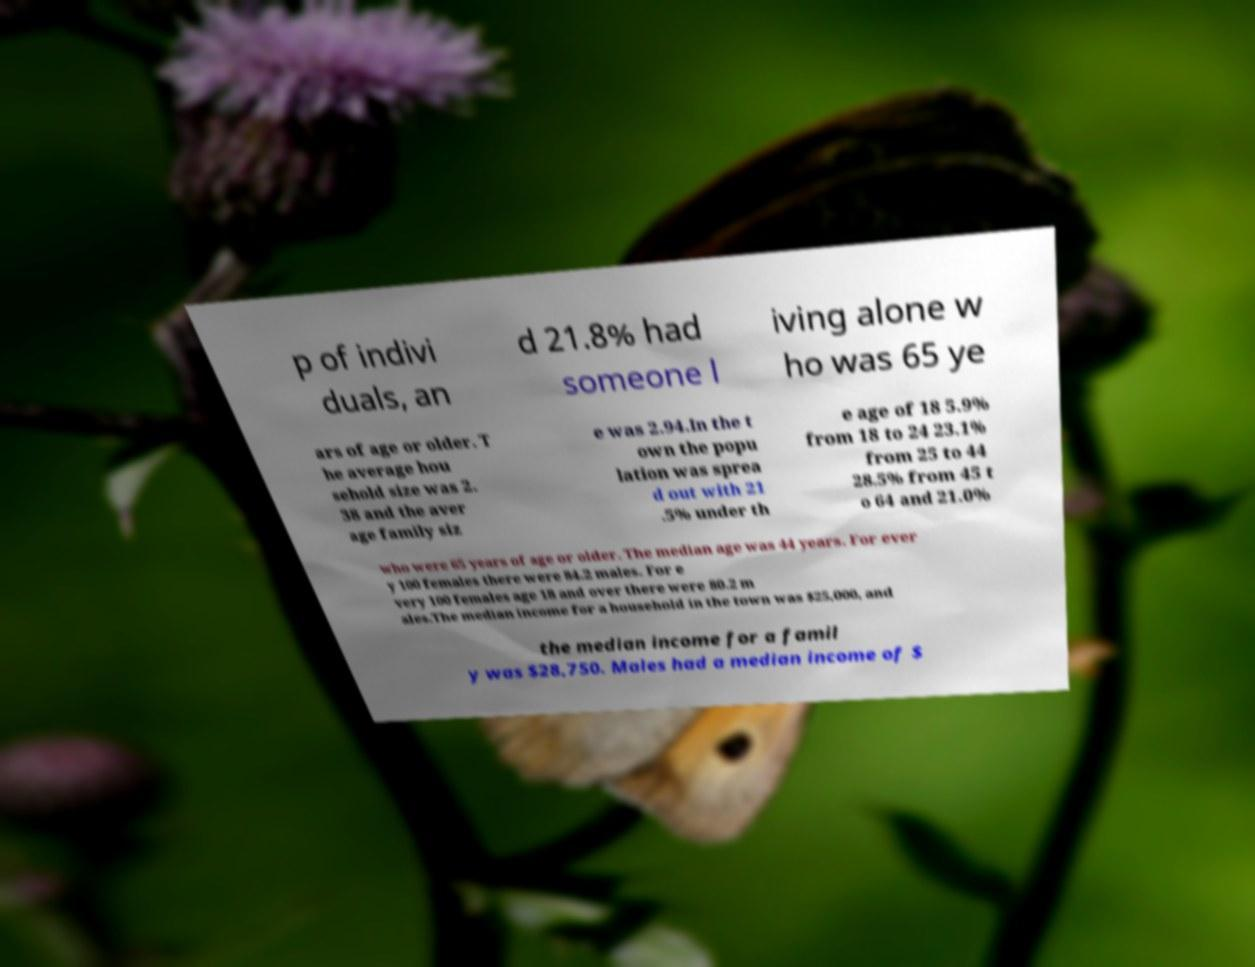Could you assist in decoding the text presented in this image and type it out clearly? p of indivi duals, an d 21.8% had someone l iving alone w ho was 65 ye ars of age or older. T he average hou sehold size was 2. 38 and the aver age family siz e was 2.94.In the t own the popu lation was sprea d out with 21 .5% under th e age of 18 5.9% from 18 to 24 23.1% from 25 to 44 28.5% from 45 t o 64 and 21.0% who were 65 years of age or older. The median age was 44 years. For ever y 100 females there were 84.2 males. For e very 100 females age 18 and over there were 80.2 m ales.The median income for a household in the town was $25,000, and the median income for a famil y was $28,750. Males had a median income of $ 